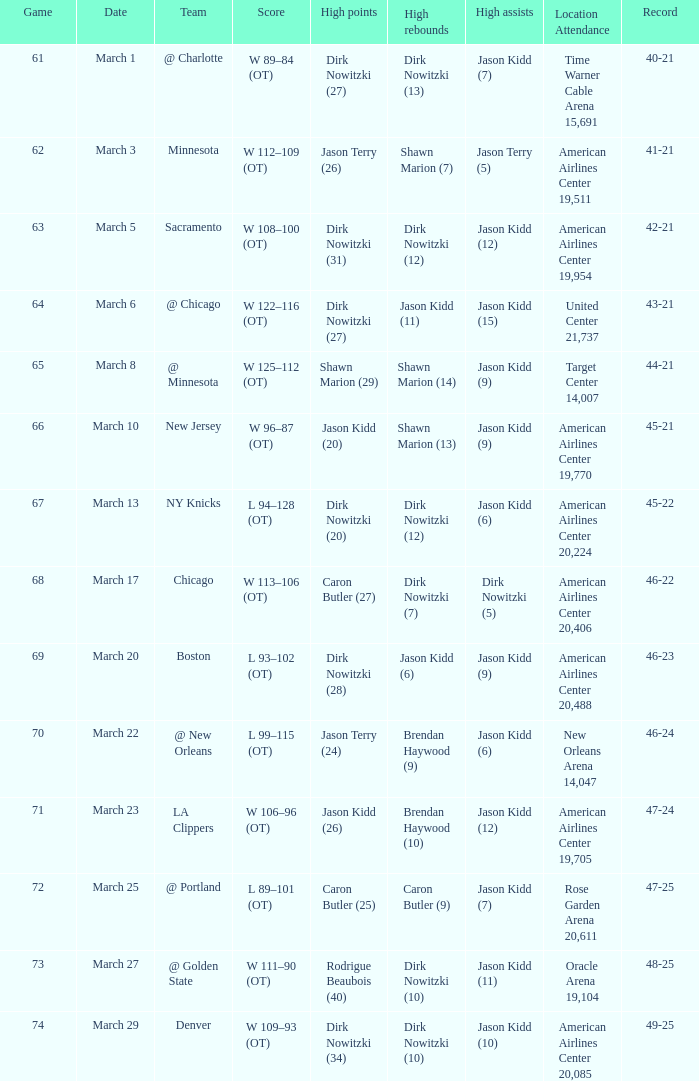How many games had been played when the Mavericks had a 46-22 record? 68.0. 